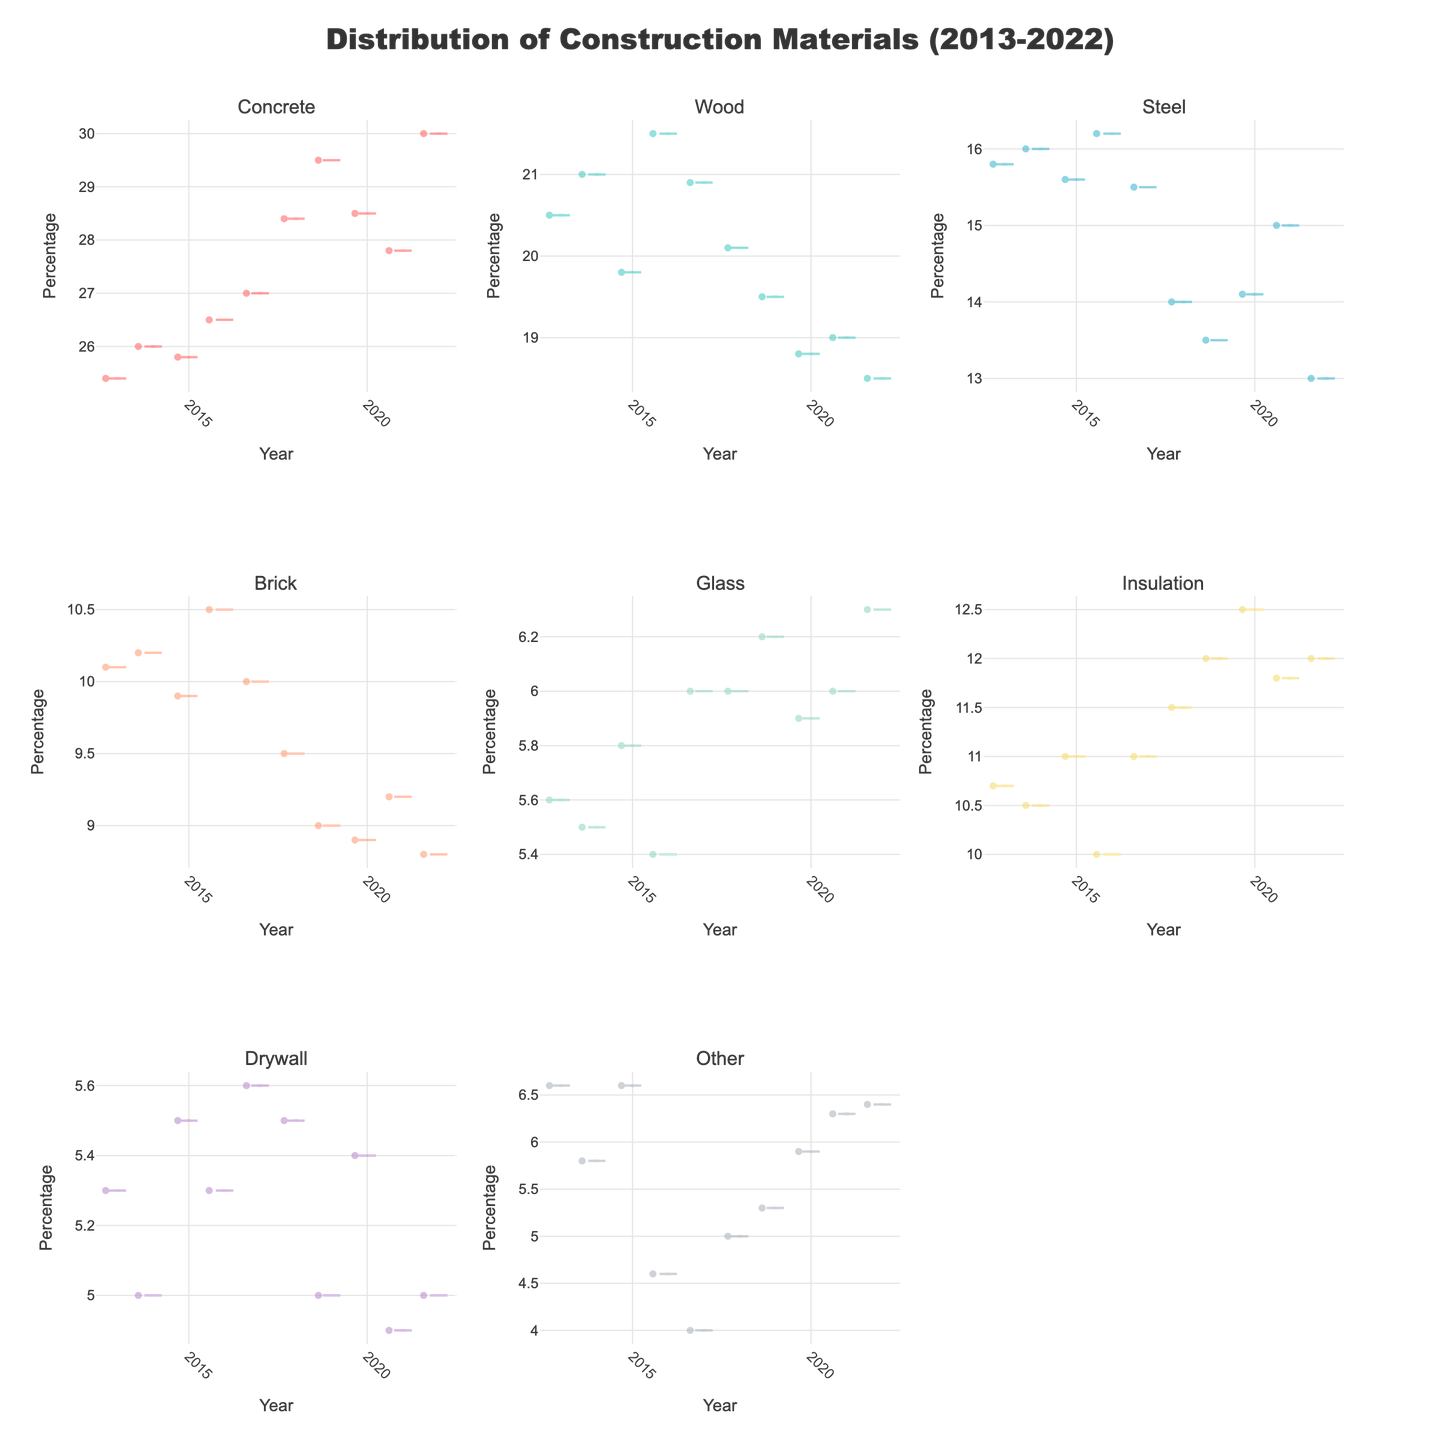Which material type has the highest percentage in 2022? Look at the subplot for each material type and identify the material with the highest y-axis value in 2022. "Concrete" has the highest percentage of 30.0%.
Answer: Concrete What is the range of percentages for Glass across the years? Check the Glass subplot and identify the minimum and maximum y-axis values. The range is 5.4 (minimum) to 6.3 (maximum).
Answer: 5.4 to 6.3 How did the percentage of Wood change from 2018 to 2022? Compare the y-axis percentage values for Wood in 2018 and 2022. In 2018, the percentage is 20.1%, and in 2022, it is 18.5%. The change is 20.1 - 18.5 = 1.6%.
Answer: Decreased by 1.6% Which material type shows the most variability in percentages over the years? Check each subplot for the spread of percentages along the y-axis. "Other" appears to have the most variability as its values spread widely compared to other materials.
Answer: Other What is the average percentage for Steel from 2013 to 2022? Add up the percentages for Steel from 2013 to 2022 and divide by the number of years. (15.8+16.0+15.6+16.2+15.5+14.0+13.5+14.1+15.0+13.0) / 10 = 148.7 / 10 = 14.87%.
Answer: 14.87% In which year does Insulation show the highest percentage? Identify the highest y-axis value in the Insulation subplot and the corresponding year. The highest percentage is in 2020 at 12.5%.
Answer: 2020 Compare the percentage trends of Concrete and Brick over the years. Look at the subplots for Concrete and Brick and compare the trends. Concrete generally increases over the years, while Brick shows a slight decrease.
Answer: Concrete increases, Brick decreases Which material had the lowest percentage in 2017? Find the material subplot with the lowest y-axis value in 2017. "Other" has the lowest percentage at 4.0%.
Answer: Other Has the percentage of Drywall remained stable over the years? Analyze the Drywall subplot for consistency in percentage values. Drywall percentages are relatively stable, fluctuating slightly between 4.9% and 5.6%.
Answer: Yes What's the median value of Wood's percentages over the years? List all percentages for Wood, sort them, and find the middle value. Percentages: [18.5, 18.8, 19.0, 19.5, 19.8, 20.1, 20.5, 20.9, 21.0, 21.5]. The median is the average of the 5th and 6th values: (19.8+20.1)/2 = 39.9/2 = 19.95%.
Answer: 19.95% 